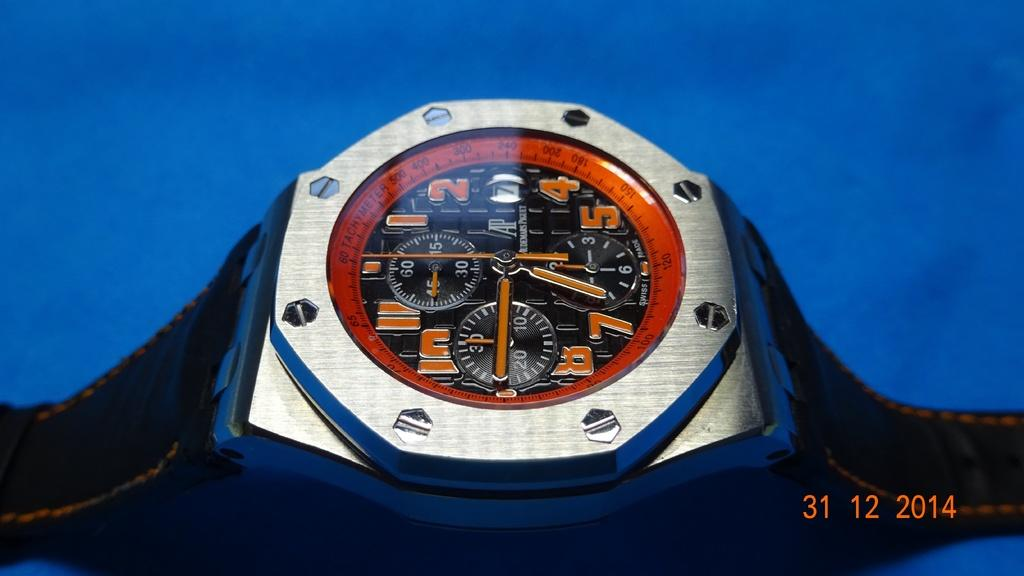<image>
Give a short and clear explanation of the subsequent image. A photograph taken on December 31. 2014 shows a watch on a blue background. 